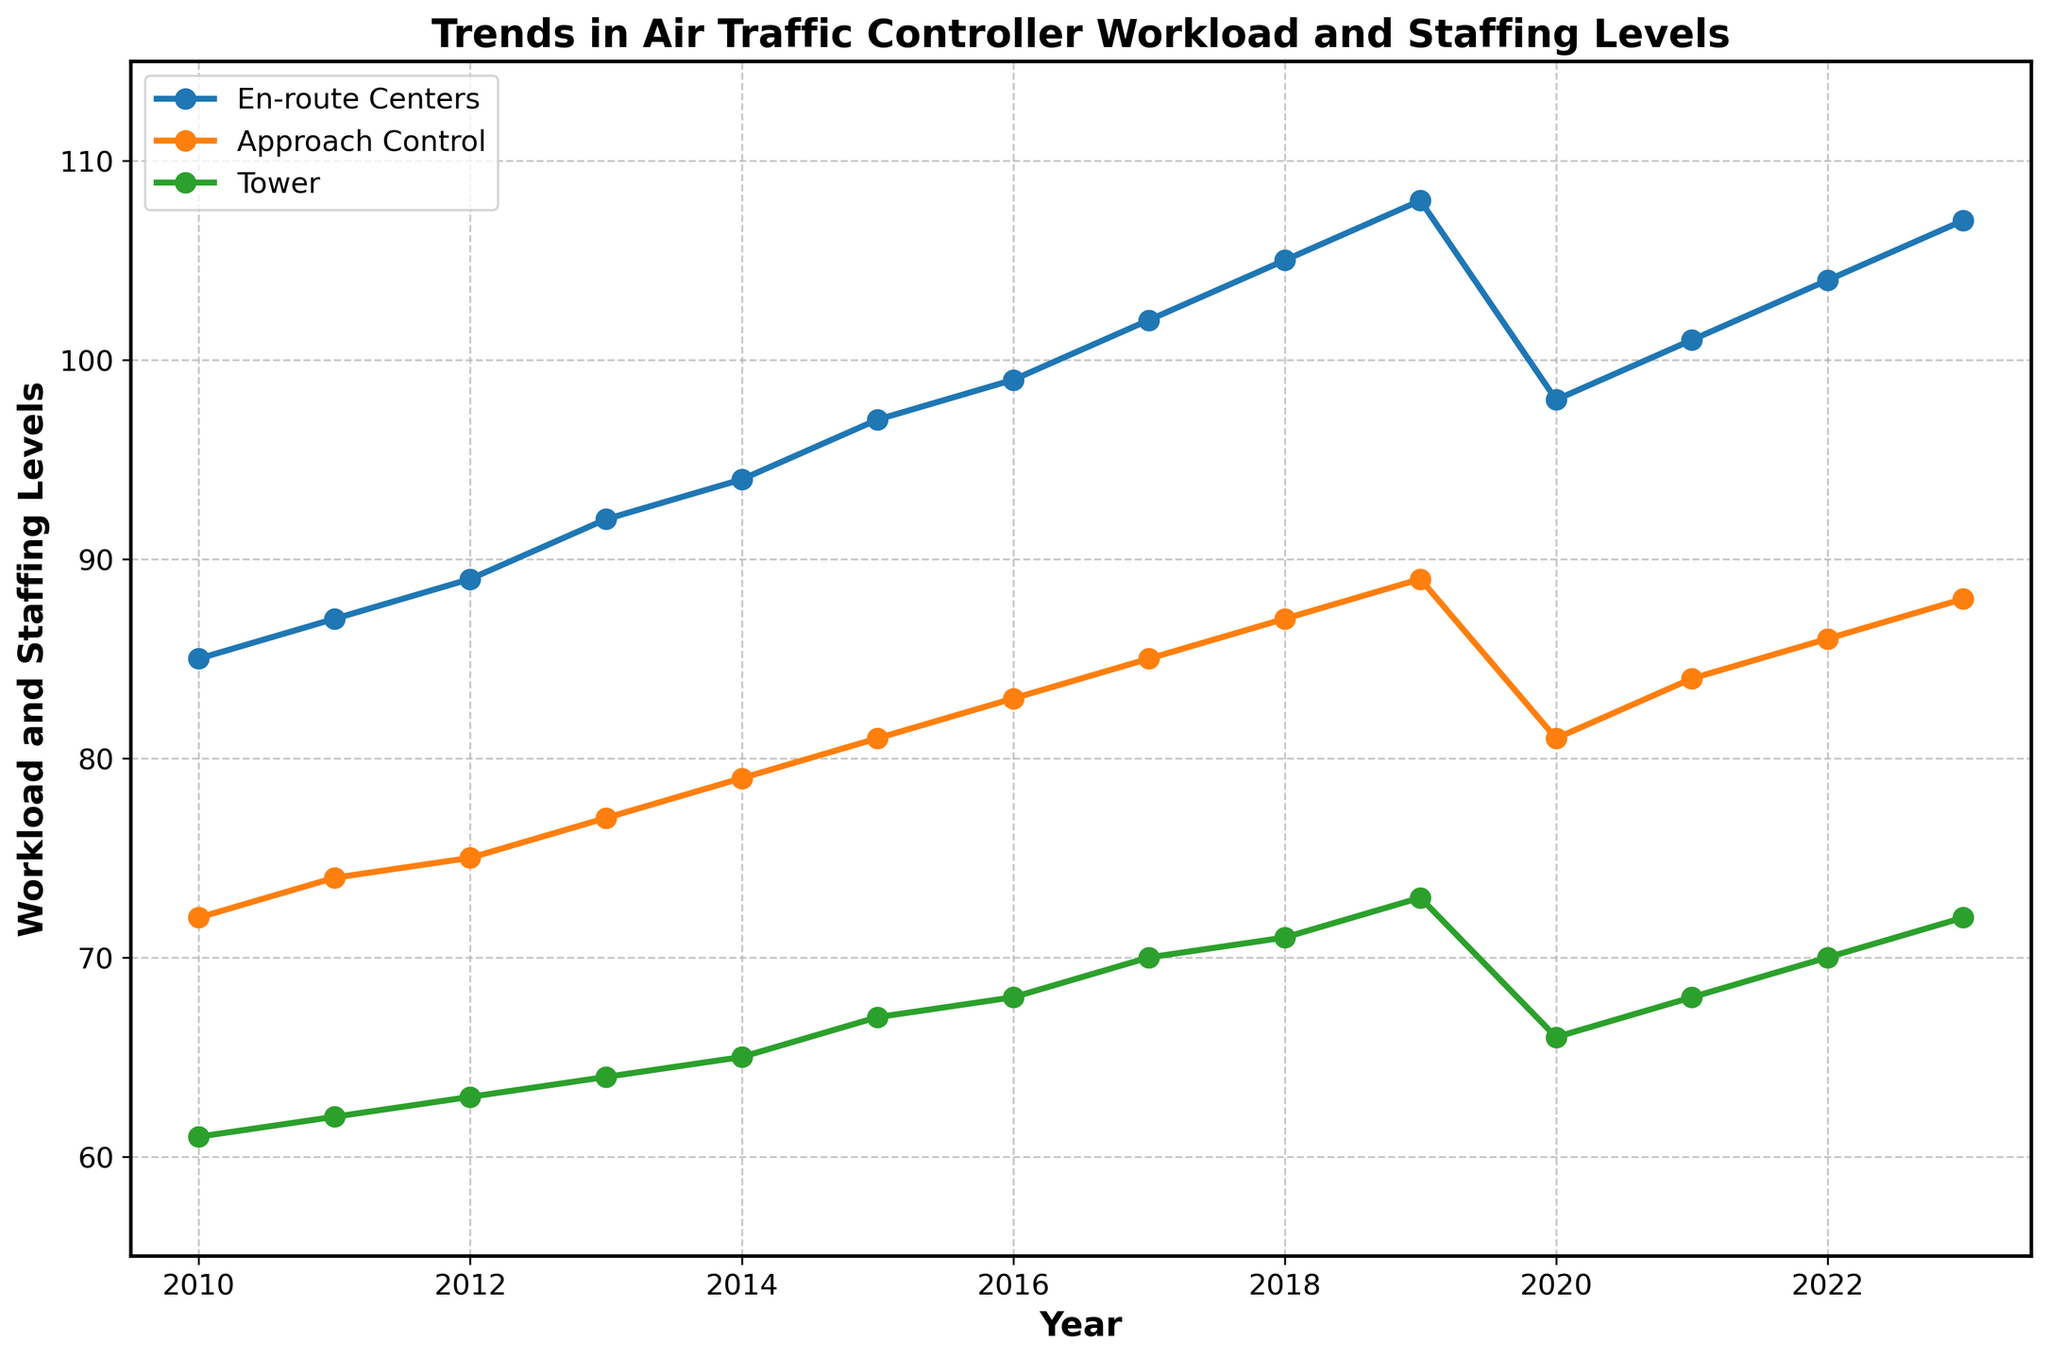Which facility type had the highest workload and staffing level in 2023? In 2023, the 'En-route Centers' had the highest value on the y-axis compared to 'Approach Control' and 'Tower', indicating it had the highest workload and staffing level.
Answer: En-route Centers By how much did the workload and staffing level for Towers increase from 2010 to 2023? To find the difference, subtract the 2010 value for Towers (61) from the 2023 value (72). This gives 72 - 61 = 11.
Answer: 11 Which year experienced a noticeable decrease in workload and staffing levels at all facility types? In 2020, there is a noticeable drop in the lines for all three facility types, indicating a decrease in workload and staffing levels.
Answer: 2020 What is the average workload and staffing level for Approach Control from 2010 to 2023? Add the values from 2010 to 2023 for Approach Control (72 + 74 + 75 + 77 + 79 + 81 + 83 + 85 + 87 + 89 + 81 + 84 + 86 + 88) and divide by the number of years (14). The sum is 1161, so average is 1161 / 14 ≈ 82.93.
Answer: 82.93 Which facility type showed the most consistent increase in workload and staffing levels from 2010 to 2019? Observe the slope of the lines for all three facility types between 2010 and 2019. The 'En-route Centers' line shows the most consistent and steady increase over that period.
Answer: En-route Centers In which year did the 'En-route Centers' facility type first exceed a workload and staffing level of 100? The line for 'En-route Centers' exceeds the value of 100 in the year 2017.
Answer: 2017 How much did the workload and staffing levels for Approach Control change during the year with the largest decrease? The largest decrease for Approach Control occurs between 2019 and 2020, dropping from 89 to 81. The change is calculated as 89 - 81 = 8.
Answer: 8 What was the workload and staffing level for Towers in 2015, and how does it compare to Approach Control in the same year? The value for Towers in 2015 is 67, whereas for Approach Control it is 81. To compare, subtract the value for Towers from Approach Control: 81 - 67 = 14.
Answer: 67; 14 Between which consecutive years did 'En-route Centers' see the largest increase in workload and staffing levels? The largest increase in 'En-route Centers' occurred between 2018 and 2019, where the values jumped from 105 to 108. The increase is 3.
Answer: 2018-2019 